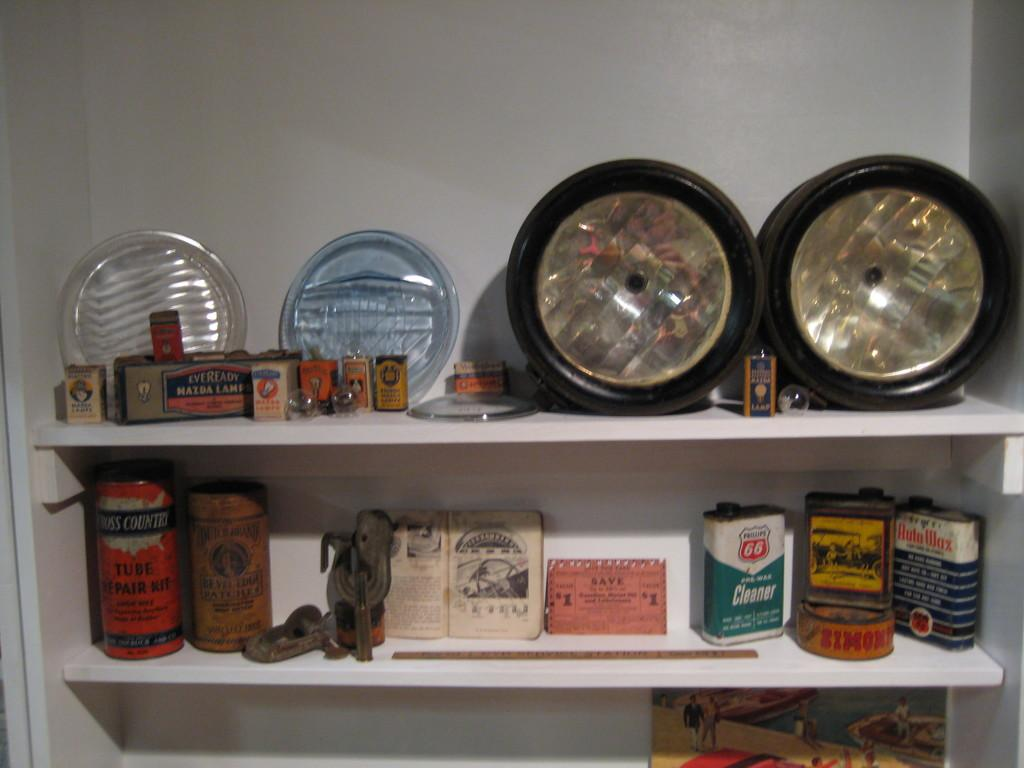<image>
Create a compact narrative representing the image presented. two shelves in a pantry, the contents including a can of autowax 